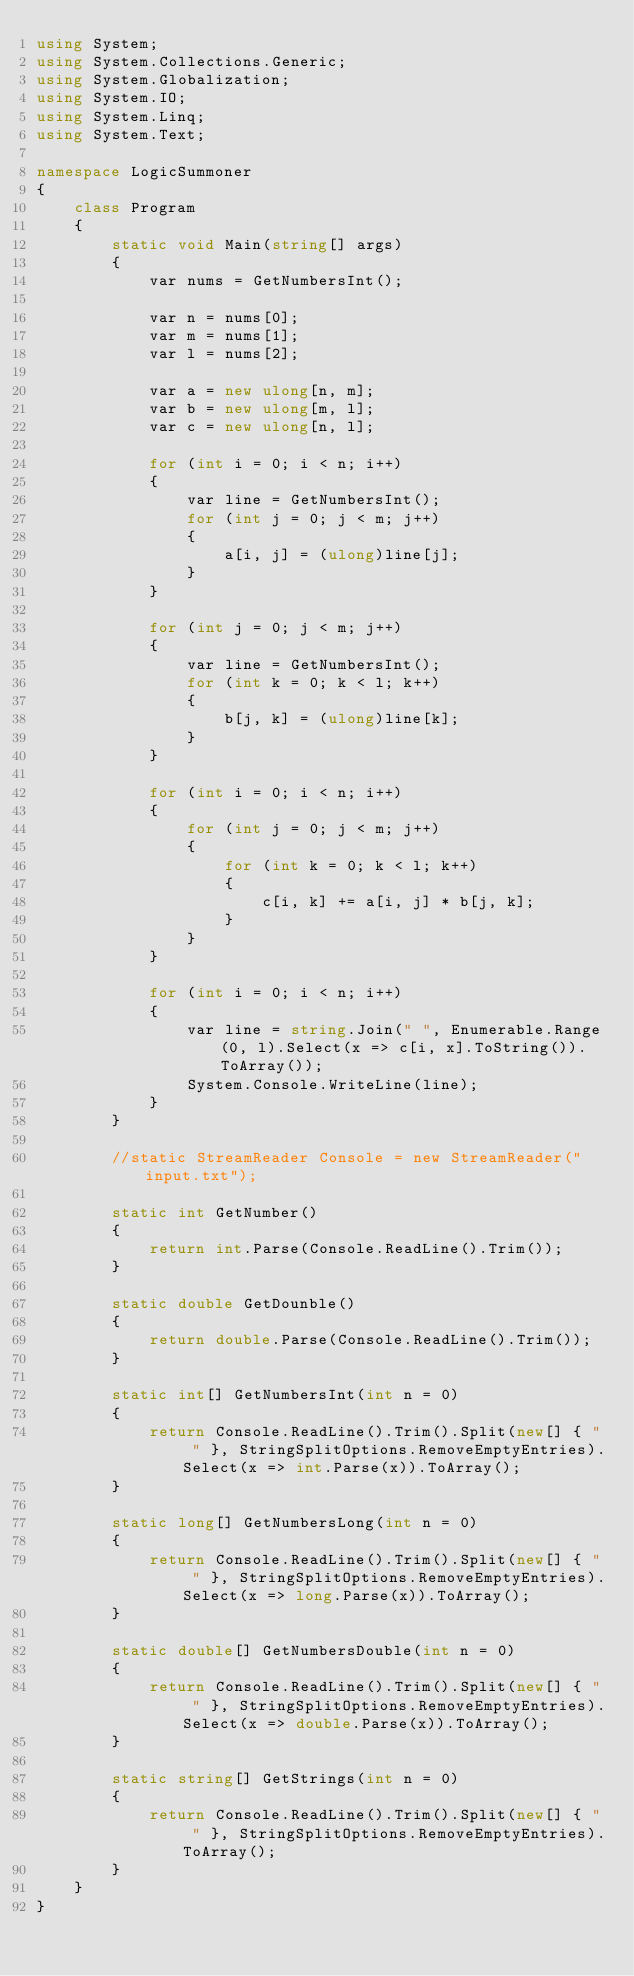Convert code to text. <code><loc_0><loc_0><loc_500><loc_500><_C#_>using System;
using System.Collections.Generic;
using System.Globalization;
using System.IO;
using System.Linq;
using System.Text;

namespace LogicSummoner
{
    class Program
    {
        static void Main(string[] args)
        {
            var nums = GetNumbersInt();

            var n = nums[0];
            var m = nums[1];
            var l = nums[2];

            var a = new ulong[n, m];
            var b = new ulong[m, l];
            var c = new ulong[n, l];

            for (int i = 0; i < n; i++)
            {
                var line = GetNumbersInt();
                for (int j = 0; j < m; j++)
                {
                    a[i, j] = (ulong)line[j];
                }
            }

            for (int j = 0; j < m; j++)
            {
                var line = GetNumbersInt();
                for (int k = 0; k < l; k++)
                {
                    b[j, k] = (ulong)line[k];
                }
            }

            for (int i = 0; i < n; i++)
            {
                for (int j = 0; j < m; j++)
                {
                    for (int k = 0; k < l; k++)
                    {
                        c[i, k] += a[i, j] * b[j, k];
                    }
                }
            }

            for (int i = 0; i < n; i++)
            {
                var line = string.Join(" ", Enumerable.Range(0, l).Select(x => c[i, x].ToString()).ToArray());
                System.Console.WriteLine(line);
            }
        }

        //static StreamReader Console = new StreamReader("input.txt");

        static int GetNumber()
        {
            return int.Parse(Console.ReadLine().Trim());
        }

        static double GetDounble()
        {
            return double.Parse(Console.ReadLine().Trim());
        }

        static int[] GetNumbersInt(int n = 0)
        {
            return Console.ReadLine().Trim().Split(new[] { " " }, StringSplitOptions.RemoveEmptyEntries).Select(x => int.Parse(x)).ToArray();
        }

        static long[] GetNumbersLong(int n = 0)
        {
            return Console.ReadLine().Trim().Split(new[] { " " }, StringSplitOptions.RemoveEmptyEntries).Select(x => long.Parse(x)).ToArray();
        }

        static double[] GetNumbersDouble(int n = 0)
        {
            return Console.ReadLine().Trim().Split(new[] { " " }, StringSplitOptions.RemoveEmptyEntries).Select(x => double.Parse(x)).ToArray();
        }

        static string[] GetStrings(int n = 0)
        {
            return Console.ReadLine().Trim().Split(new[] { " " }, StringSplitOptions.RemoveEmptyEntries).ToArray();
        }
    }
}</code> 